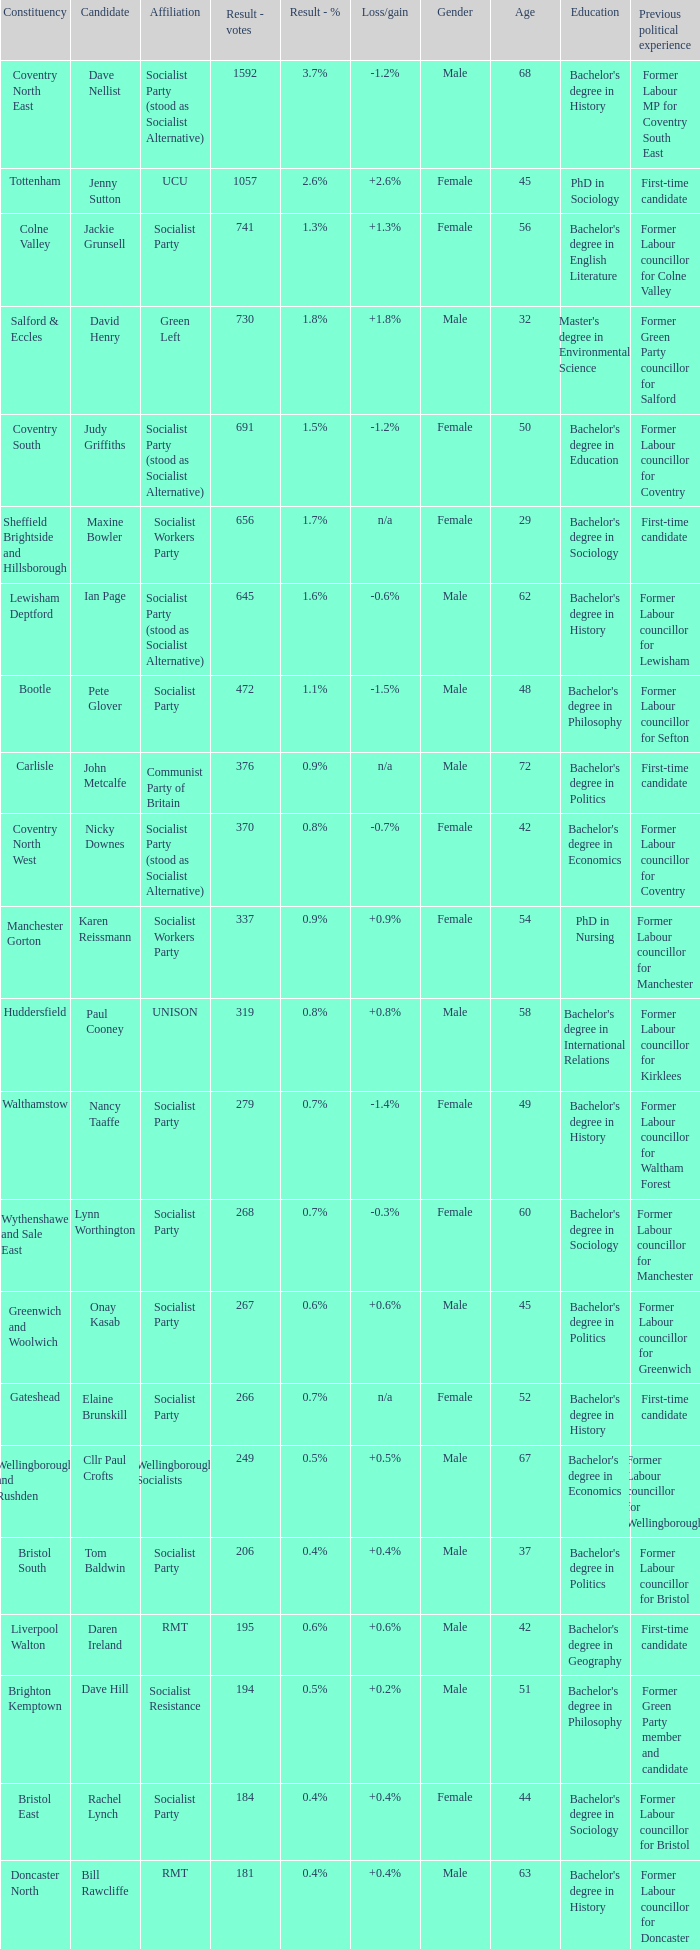What is the largest vote result if loss/gain is -0.5%? 133.0. 